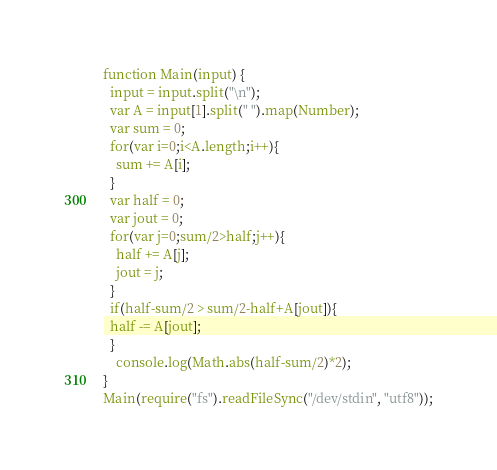Convert code to text. <code><loc_0><loc_0><loc_500><loc_500><_JavaScript_>function Main(input) {
  input = input.split("\n");
  var A = input[1].split(" ").map(Number);
  var sum = 0;
  for(var i=0;i<A.length;i++){
    sum += A[i];
  }
  var half = 0;
  var jout = 0;
  for(var j=0;sum/2>half;j++){
    half += A[j];
    jout = j;
  }
  if(half-sum/2 > sum/2-half+A[jout]){
  half -= A[jout];
  }
	console.log(Math.abs(half-sum/2)*2);
}
Main(require("fs").readFileSync("/dev/stdin", "utf8"));</code> 